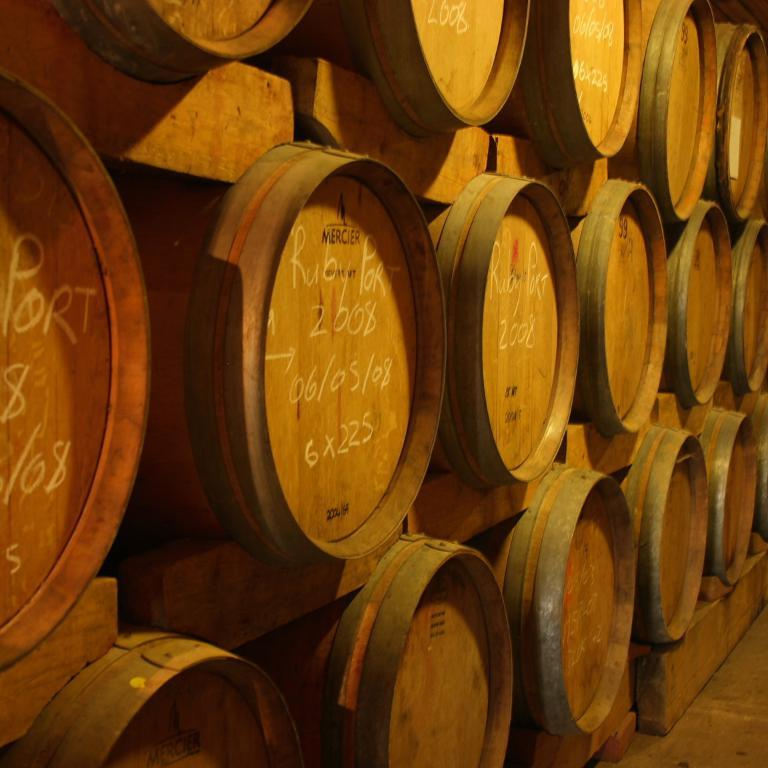What is the main subject of the image? The main subject of the image is many barrels. Can you describe any specific features of the barrels? Yes, there is writing on the barrels. What type of destruction can be seen happening to the barrels in the image? There is no destruction happening to the barrels in the image; they are simply standing with writing on them. Can you tell me who is sitting on the throne among the barrels in the image? There is no throne present among the barrels in the image. 